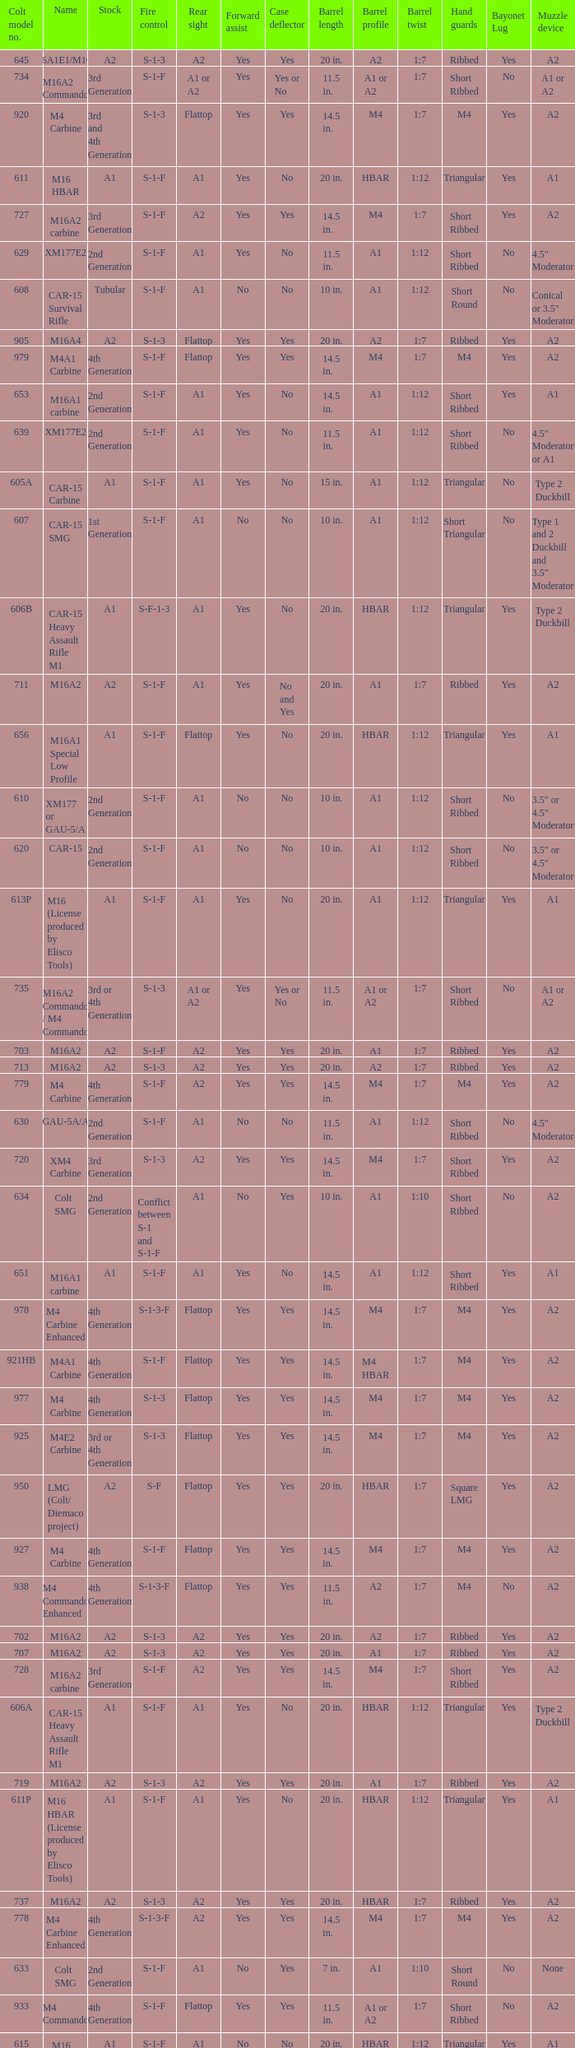What is the rear sight in the Cole model no. 735? A1 or A2. 